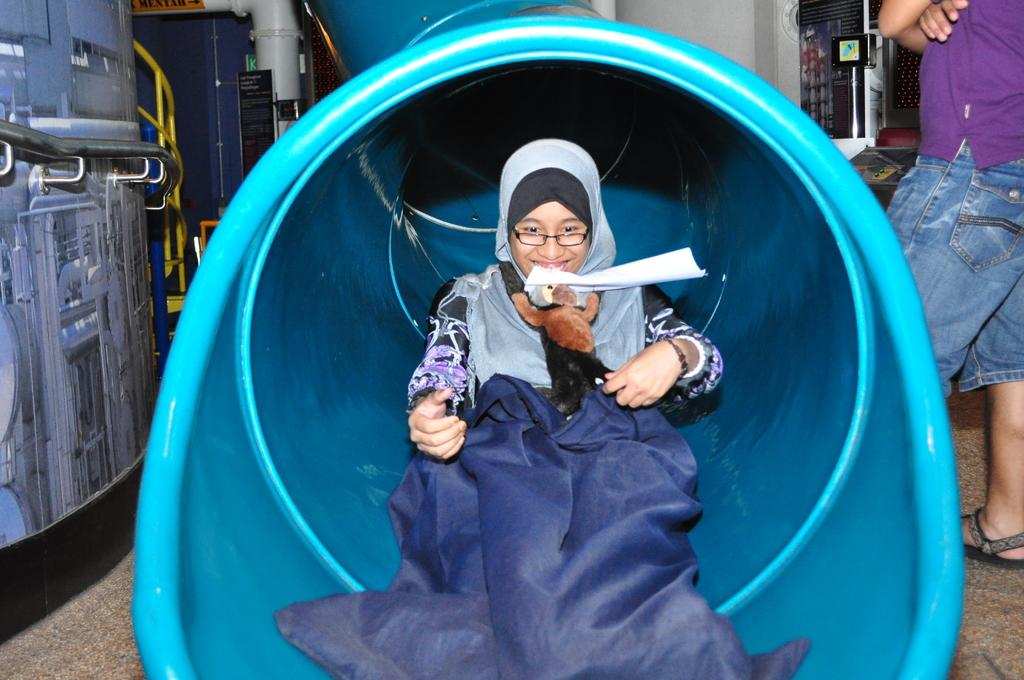Who is the main subject in the image? There is an Arab girl in the image. What is the girl holding in the image? The girl is holding a teddy bear. Where is the girl located in the image? The girl is inside a pipe. Who else can be seen in the image? There is a man standing on the right side of the image. What can be seen on the left side of the image? There appears to be a machine on the left side of the image. What type of wine is being served at the dinner table in the image? There is no dinner table or wine present in the image. 